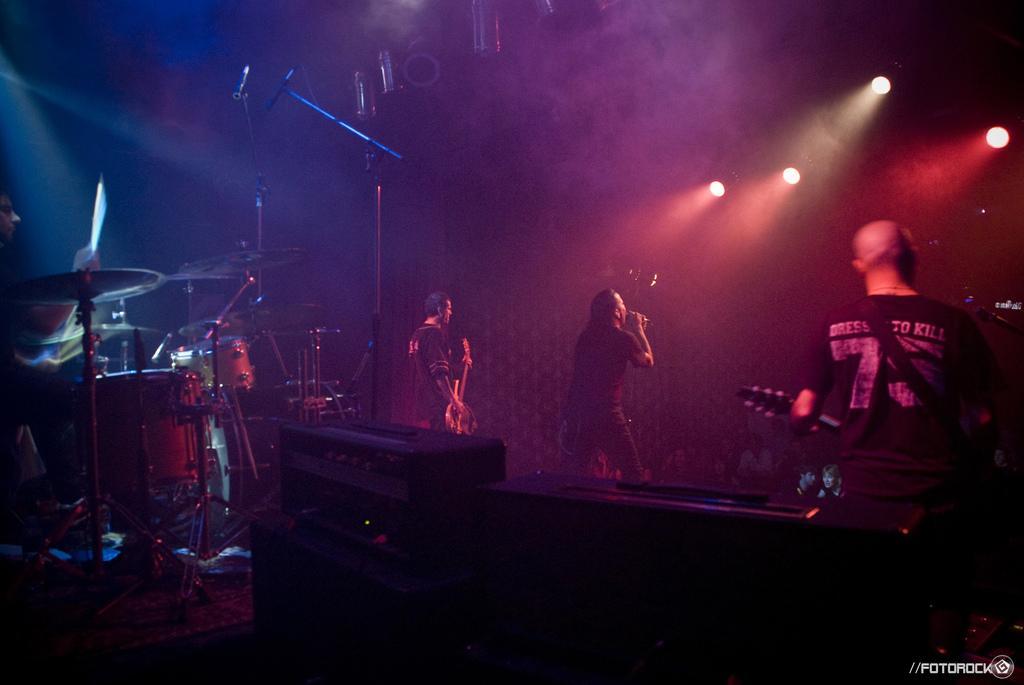In one or two sentences, can you explain what this image depicts? There are 3 people here on the stage performing by playing musical instruments. In the middle a man is singing. Behind them there are musical instruments and a mic stands. 